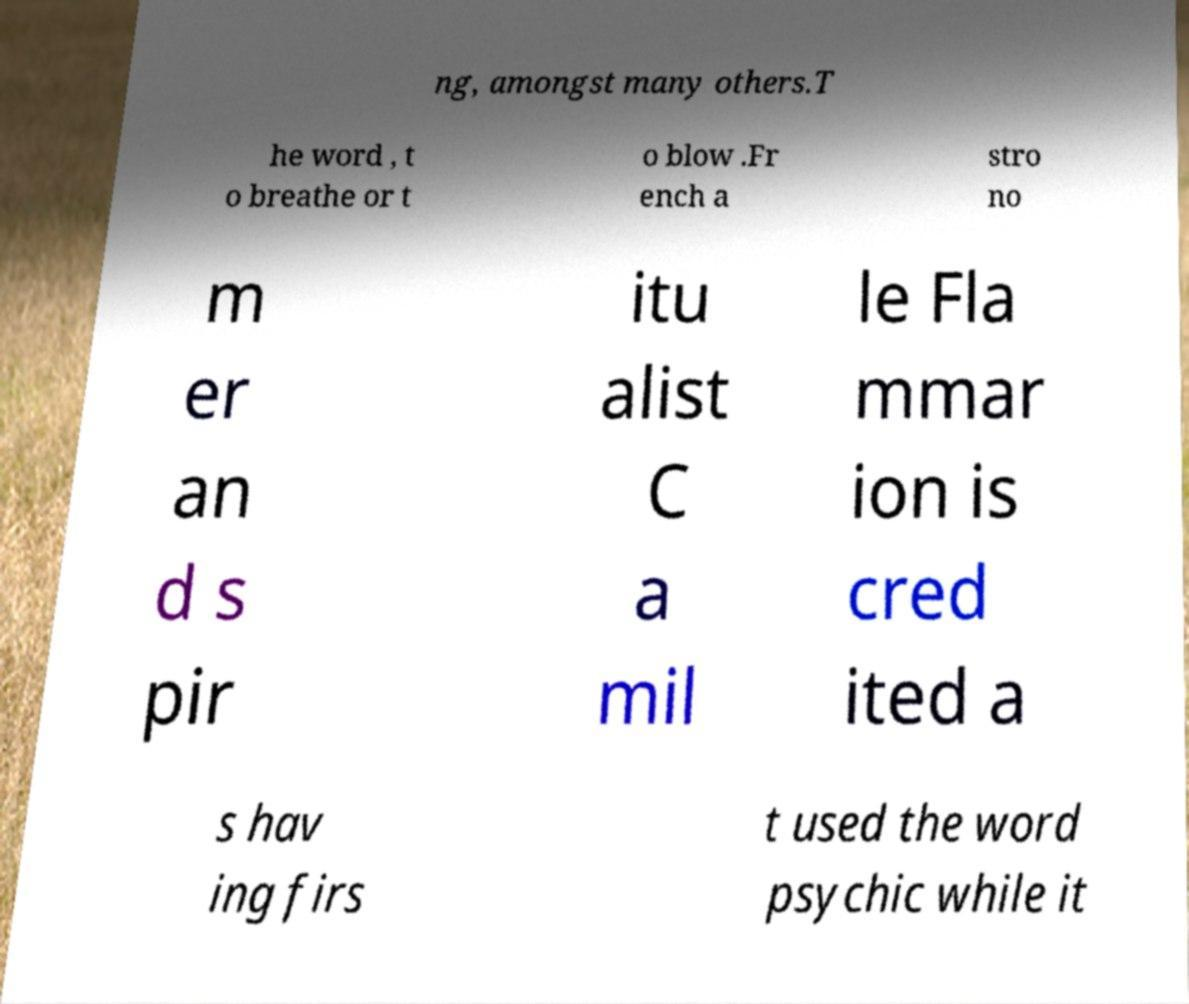Could you extract and type out the text from this image? ng, amongst many others.T he word , t o breathe or t o blow .Fr ench a stro no m er an d s pir itu alist C a mil le Fla mmar ion is cred ited a s hav ing firs t used the word psychic while it 